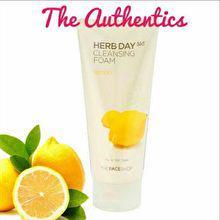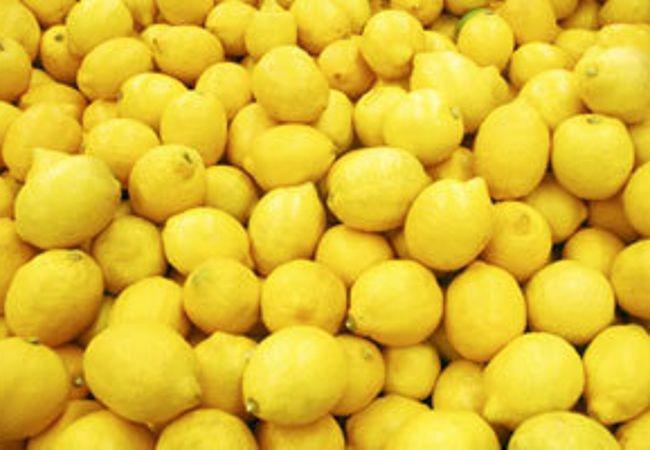The first image is the image on the left, the second image is the image on the right. Considering the images on both sides, is "The left image depicts a cut lemon half in front of a whole lemon and green leaves and include an upright product container, and the right image contains a mass of whole lemons only." valid? Answer yes or no. Yes. The first image is the image on the left, the second image is the image on the right. Assess this claim about the two images: "There is a real sliced lemon in the left image.". Correct or not? Answer yes or no. Yes. 